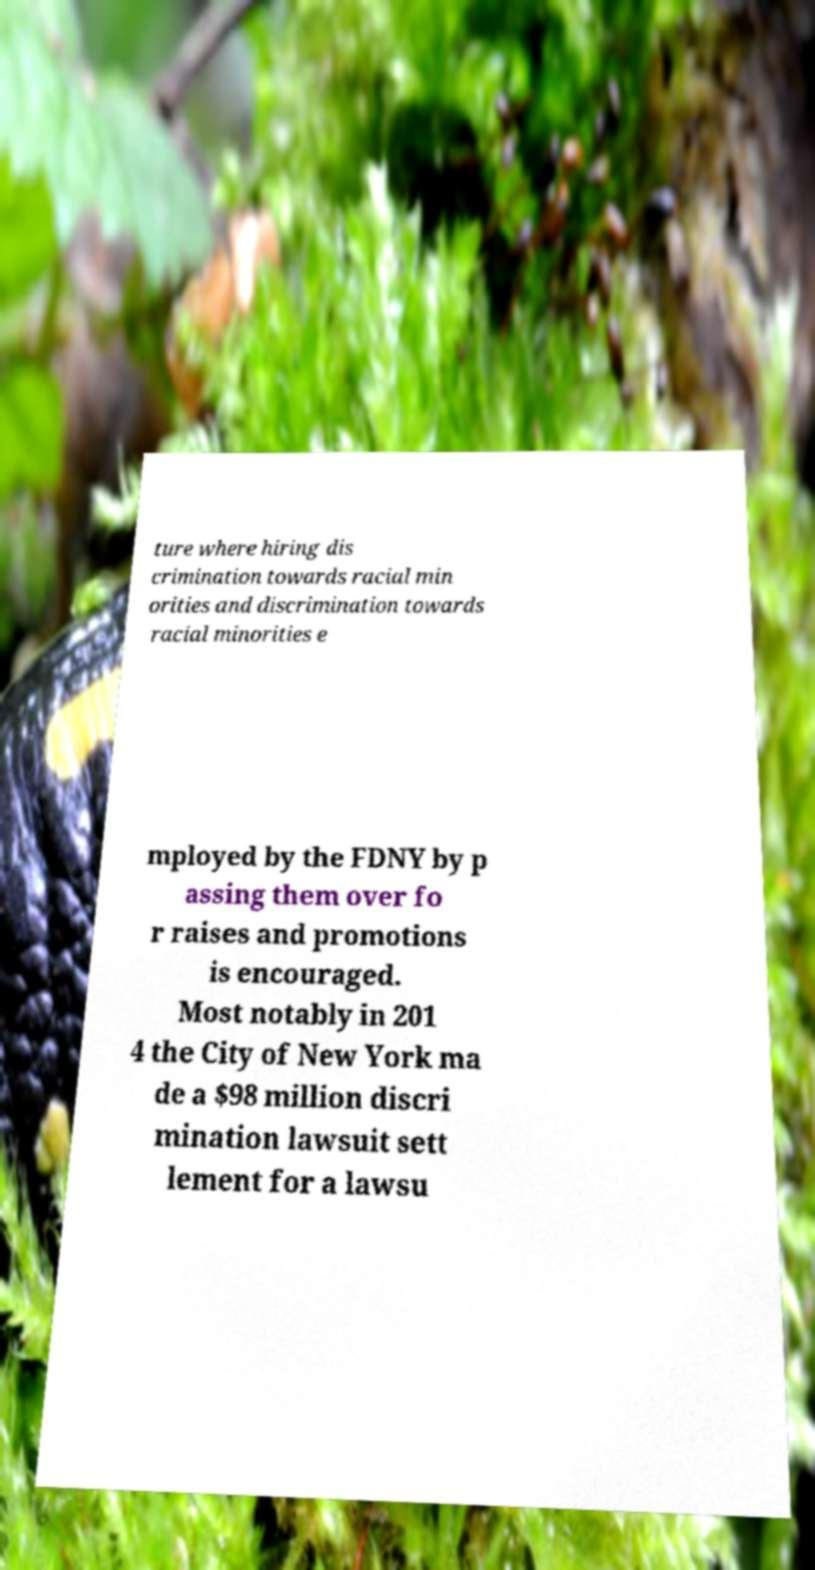I need the written content from this picture converted into text. Can you do that? ture where hiring dis crimination towards racial min orities and discrimination towards racial minorities e mployed by the FDNY by p assing them over fo r raises and promotions is encouraged. Most notably in 201 4 the City of New York ma de a $98 million discri mination lawsuit sett lement for a lawsu 